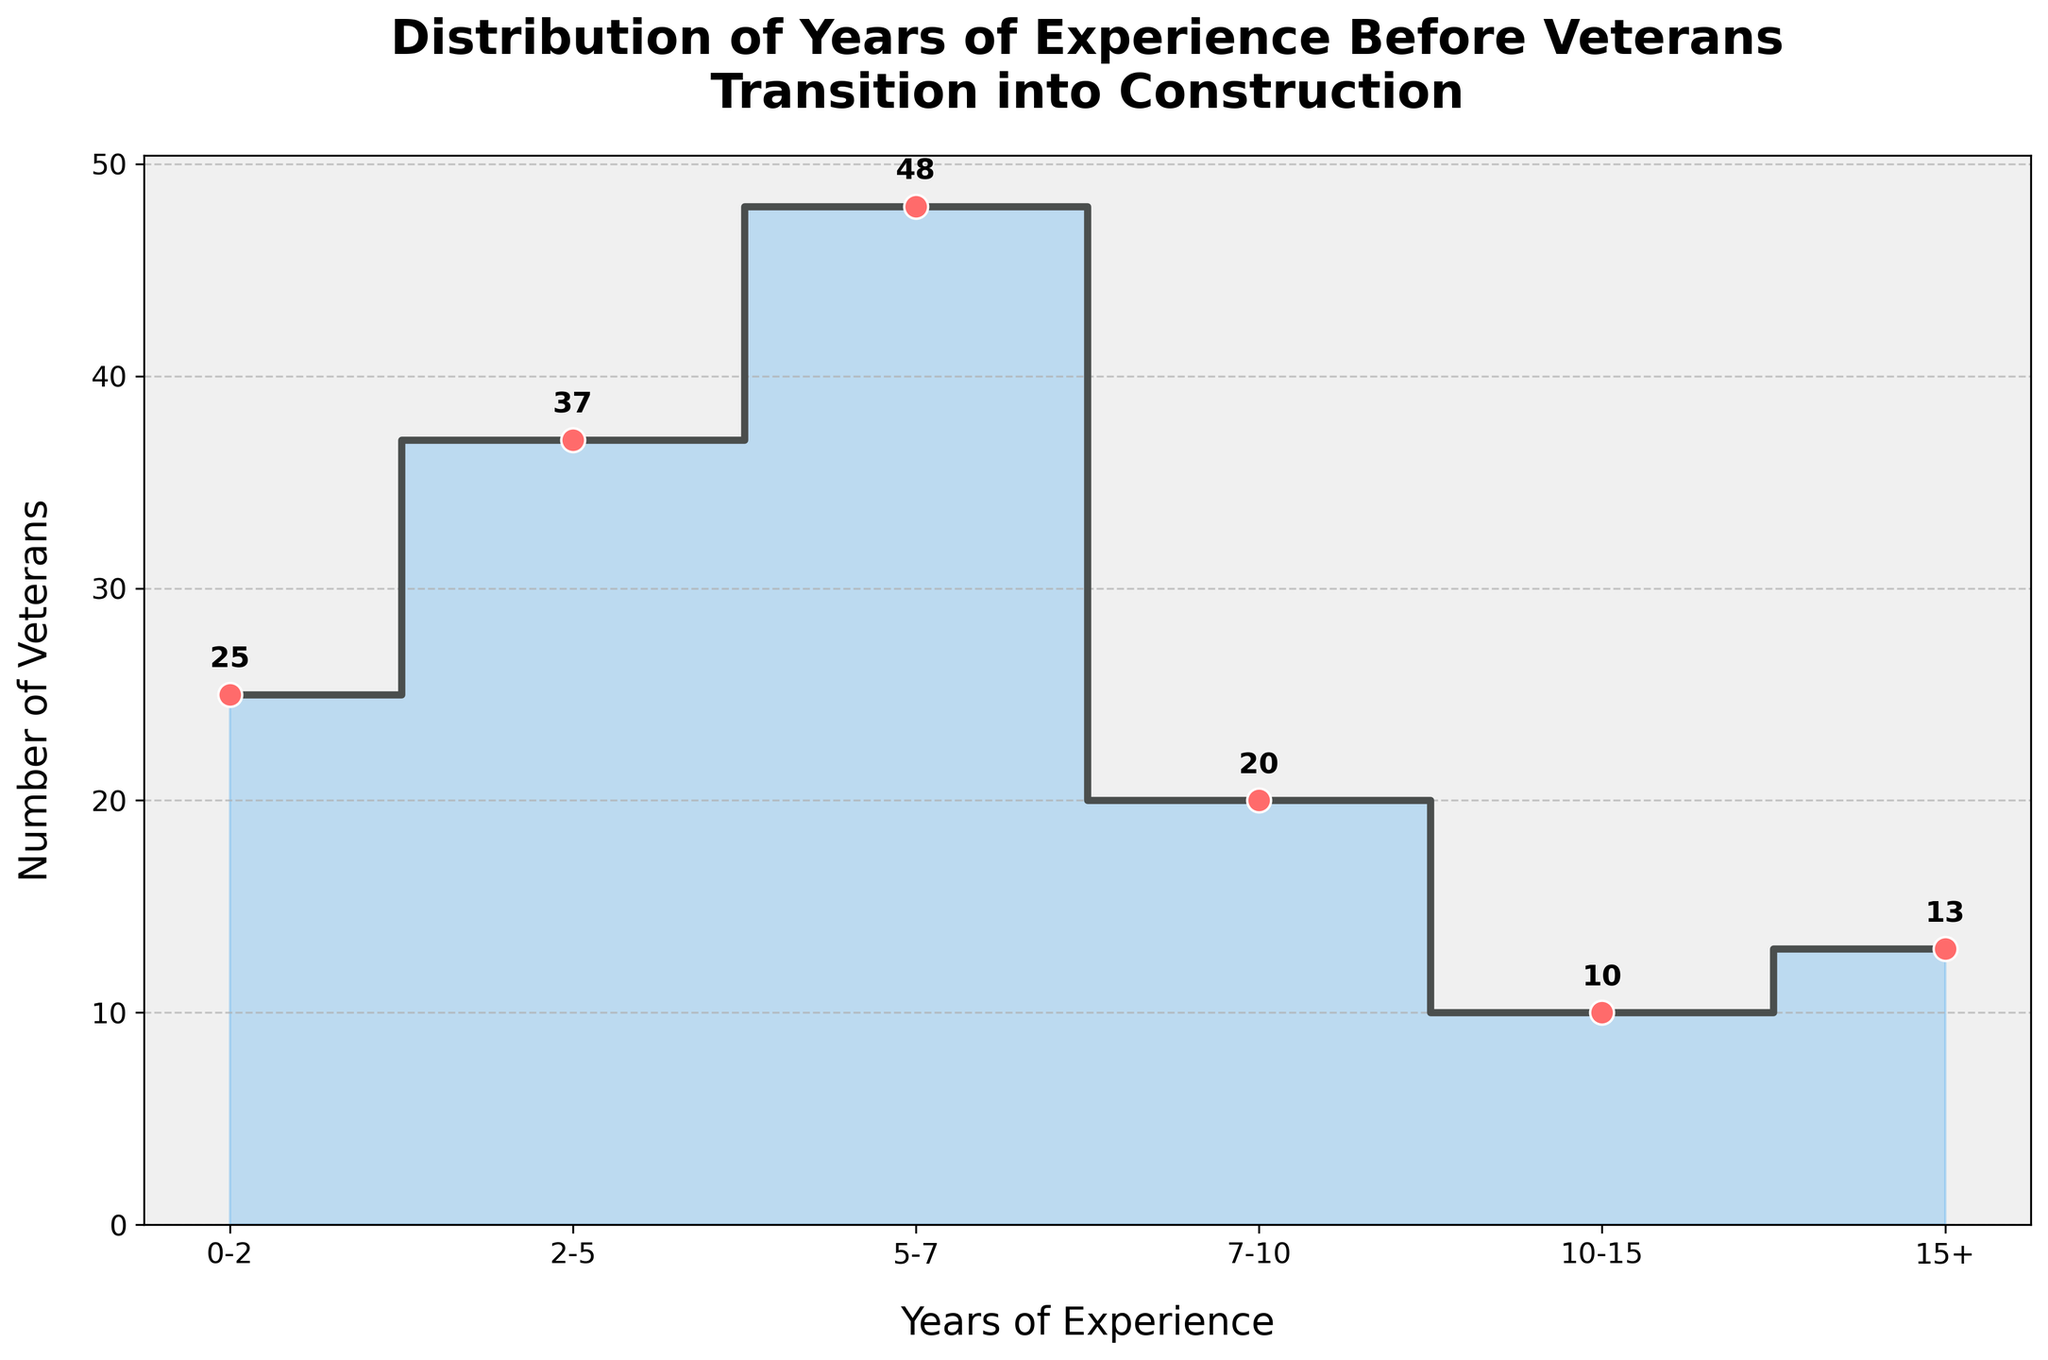What is the title of the figure? The title of the figure is displayed prominently above the plot. It reads "Distribution of Years of Experience Before Veterans Transition into Construction" and is bolded for clarity.
Answer: Distribution of Years of Experience Before Veterans Transition into Construction Which range of years has the highest number of veterans? The highest point on the y-axis of the stair plot corresponds to the "5-7" range, marking the peak number on the plot.
Answer: 5-7 How many veterans have 0-2 years of experience? Two data points exist within the "0-2" range in the figure. Adding the values above the markers, we get 15 (Bechtel) + 10 (Clayco) = 25.
Answer: 25 What is the total number of veterans with more than 10 years of experience? The relevant ranges are "10-15" and "15+" years of experience. Summing the values from the figure: 10 (10-15) + 5 (Fluor) + 8 (Lendlease) = 23.
Answer: 23 Compare the number of veterans with 2-5 years and 5-7 years of experience. Which is larger and by how much? The number for "2-5" years of experience is the sum of 25 (Turner Construction) + 12 (Jacobs Engineering) = 37, while for "5-7" years, it is 30 (Kiewit) + 18 (Whiting-Turner) = 48. Then, calculate the difference: 48 - 37 = 11.
Answer: 5-7 is larger by 11 What is the median number of veterans across all ranges? The data points are (25, 37, 48, 20, 10, 13), arranged as (10, 13, 20, 25, 37, 48). The median is found by averaging the middle two values: (20 + 25) / 2 = 22.5.
Answer: 22.5 What is the average number of veterans per range? Sum all values and divide by the number of ranges: (25 + 37 + 48 + 20 + 10 + 13) / 6 = 153 / 6 ≈ 25.5.
Answer: 25.5 Which company has the most veterans with 5-7 years of experience? From the description, the highest number within the "5-7" years range is for Kiewit with 30 veterans.
Answer: Kiewit Does the number of veterans increase or decrease over time in the respective ranges? Starting from the highest number in the "5-7" range, the plot shows a general decline in veterans as the years of experience increase, evidenced by the decreasing steps on the graph.
Answer: Decrease What is the difference between the number of veterans with 0-2 years of experience and 7-10 years of experience? From the plot, count 25 veterans for "0-2" years and 20 veterans for "7-10" years. Subtract to get the difference: 25 - 20 = 5.
Answer: 5 